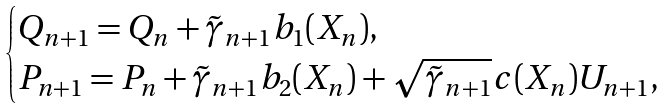Convert formula to latex. <formula><loc_0><loc_0><loc_500><loc_500>\begin{cases} Q _ { n + 1 } = Q _ { n } + \tilde { \gamma } _ { n + 1 } b _ { 1 } ( X _ { n } ) , \\ P _ { n + 1 } = P _ { n } + \tilde { \gamma } _ { n + 1 } b _ { 2 } ( X _ { n } ) + \sqrt { \tilde { \gamma } _ { n + 1 } } c ( X _ { n } ) U _ { n + 1 } , \end{cases}</formula> 